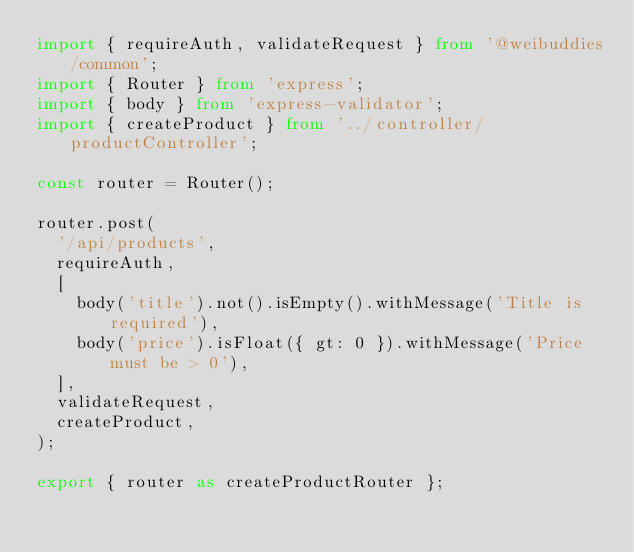Convert code to text. <code><loc_0><loc_0><loc_500><loc_500><_TypeScript_>import { requireAuth, validateRequest } from '@weibuddies/common';
import { Router } from 'express';
import { body } from 'express-validator';
import { createProduct } from '../controller/productController';

const router = Router();

router.post(
  '/api/products',
  requireAuth,
  [
    body('title').not().isEmpty().withMessage('Title is required'),
    body('price').isFloat({ gt: 0 }).withMessage('Price must be > 0'),
  ],
  validateRequest,
  createProduct,
);

export { router as createProductRouter };
</code> 